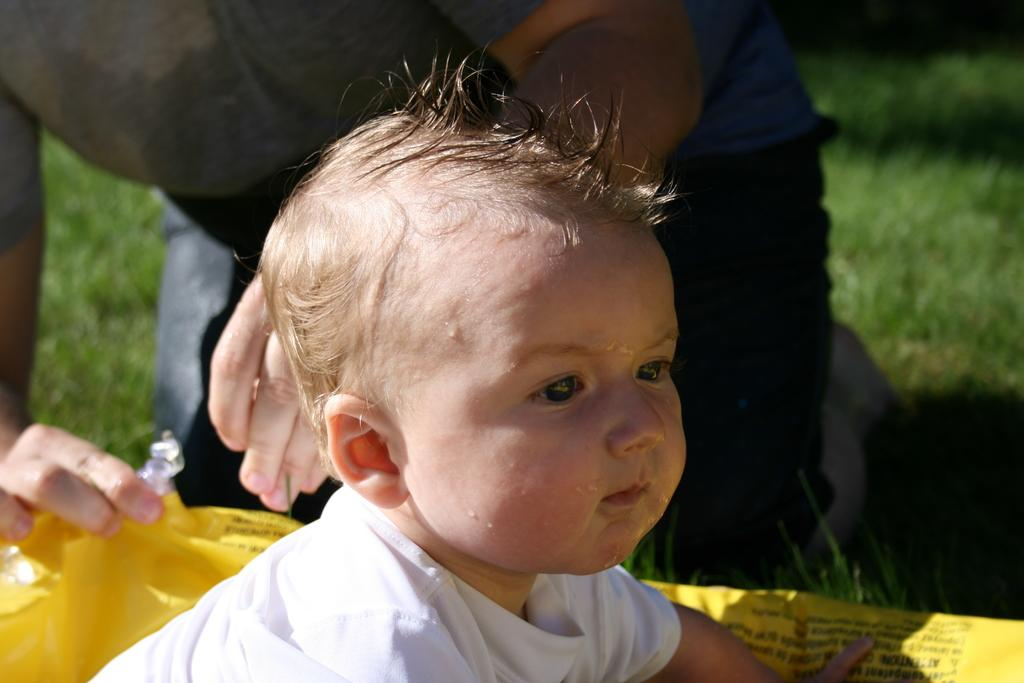How many people are in the image? There are two people in the image. What can be observed about the clothing of the people in the image? The people are wearing different color dresses. What is the color of the object between the two people? The object between the two people is yellow. What type of natural environment is visible in the background of the image? There is grass visible in the background of the image. What type of sound can be heard coming from the roof in the image? There is no roof present in the image, and therefore no sound can be heard coming from it. 